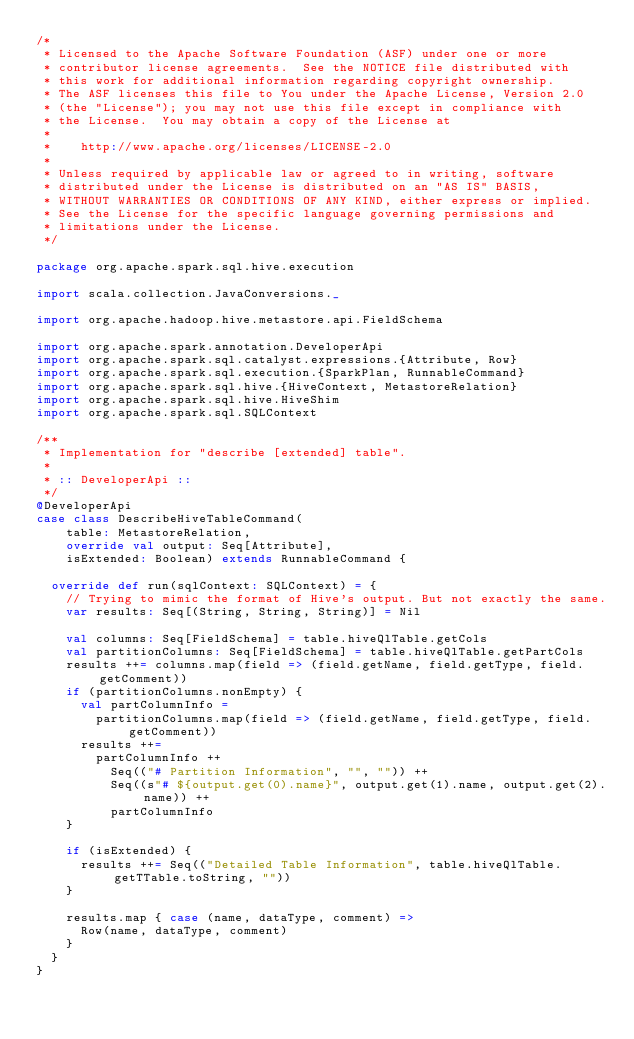<code> <loc_0><loc_0><loc_500><loc_500><_Scala_>/*
 * Licensed to the Apache Software Foundation (ASF) under one or more
 * contributor license agreements.  See the NOTICE file distributed with
 * this work for additional information regarding copyright ownership.
 * The ASF licenses this file to You under the Apache License, Version 2.0
 * (the "License"); you may not use this file except in compliance with
 * the License.  You may obtain a copy of the License at
 *
 *    http://www.apache.org/licenses/LICENSE-2.0
 *
 * Unless required by applicable law or agreed to in writing, software
 * distributed under the License is distributed on an "AS IS" BASIS,
 * WITHOUT WARRANTIES OR CONDITIONS OF ANY KIND, either express or implied.
 * See the License for the specific language governing permissions and
 * limitations under the License.
 */

package org.apache.spark.sql.hive.execution

import scala.collection.JavaConversions._

import org.apache.hadoop.hive.metastore.api.FieldSchema

import org.apache.spark.annotation.DeveloperApi
import org.apache.spark.sql.catalyst.expressions.{Attribute, Row}
import org.apache.spark.sql.execution.{SparkPlan, RunnableCommand}
import org.apache.spark.sql.hive.{HiveContext, MetastoreRelation}
import org.apache.spark.sql.hive.HiveShim
import org.apache.spark.sql.SQLContext

/**
 * Implementation for "describe [extended] table".
 *
 * :: DeveloperApi ::
 */
@DeveloperApi
case class DescribeHiveTableCommand(
    table: MetastoreRelation,
    override val output: Seq[Attribute],
    isExtended: Boolean) extends RunnableCommand {

  override def run(sqlContext: SQLContext) = {
    // Trying to mimic the format of Hive's output. But not exactly the same.
    var results: Seq[(String, String, String)] = Nil

    val columns: Seq[FieldSchema] = table.hiveQlTable.getCols
    val partitionColumns: Seq[FieldSchema] = table.hiveQlTable.getPartCols
    results ++= columns.map(field => (field.getName, field.getType, field.getComment))
    if (partitionColumns.nonEmpty) {
      val partColumnInfo =
        partitionColumns.map(field => (field.getName, field.getType, field.getComment))
      results ++=
        partColumnInfo ++
          Seq(("# Partition Information", "", "")) ++
          Seq((s"# ${output.get(0).name}", output.get(1).name, output.get(2).name)) ++
          partColumnInfo
    }

    if (isExtended) {
      results ++= Seq(("Detailed Table Information", table.hiveQlTable.getTTable.toString, ""))
    }

    results.map { case (name, dataType, comment) =>
      Row(name, dataType, comment)
    }
  }
}
</code> 